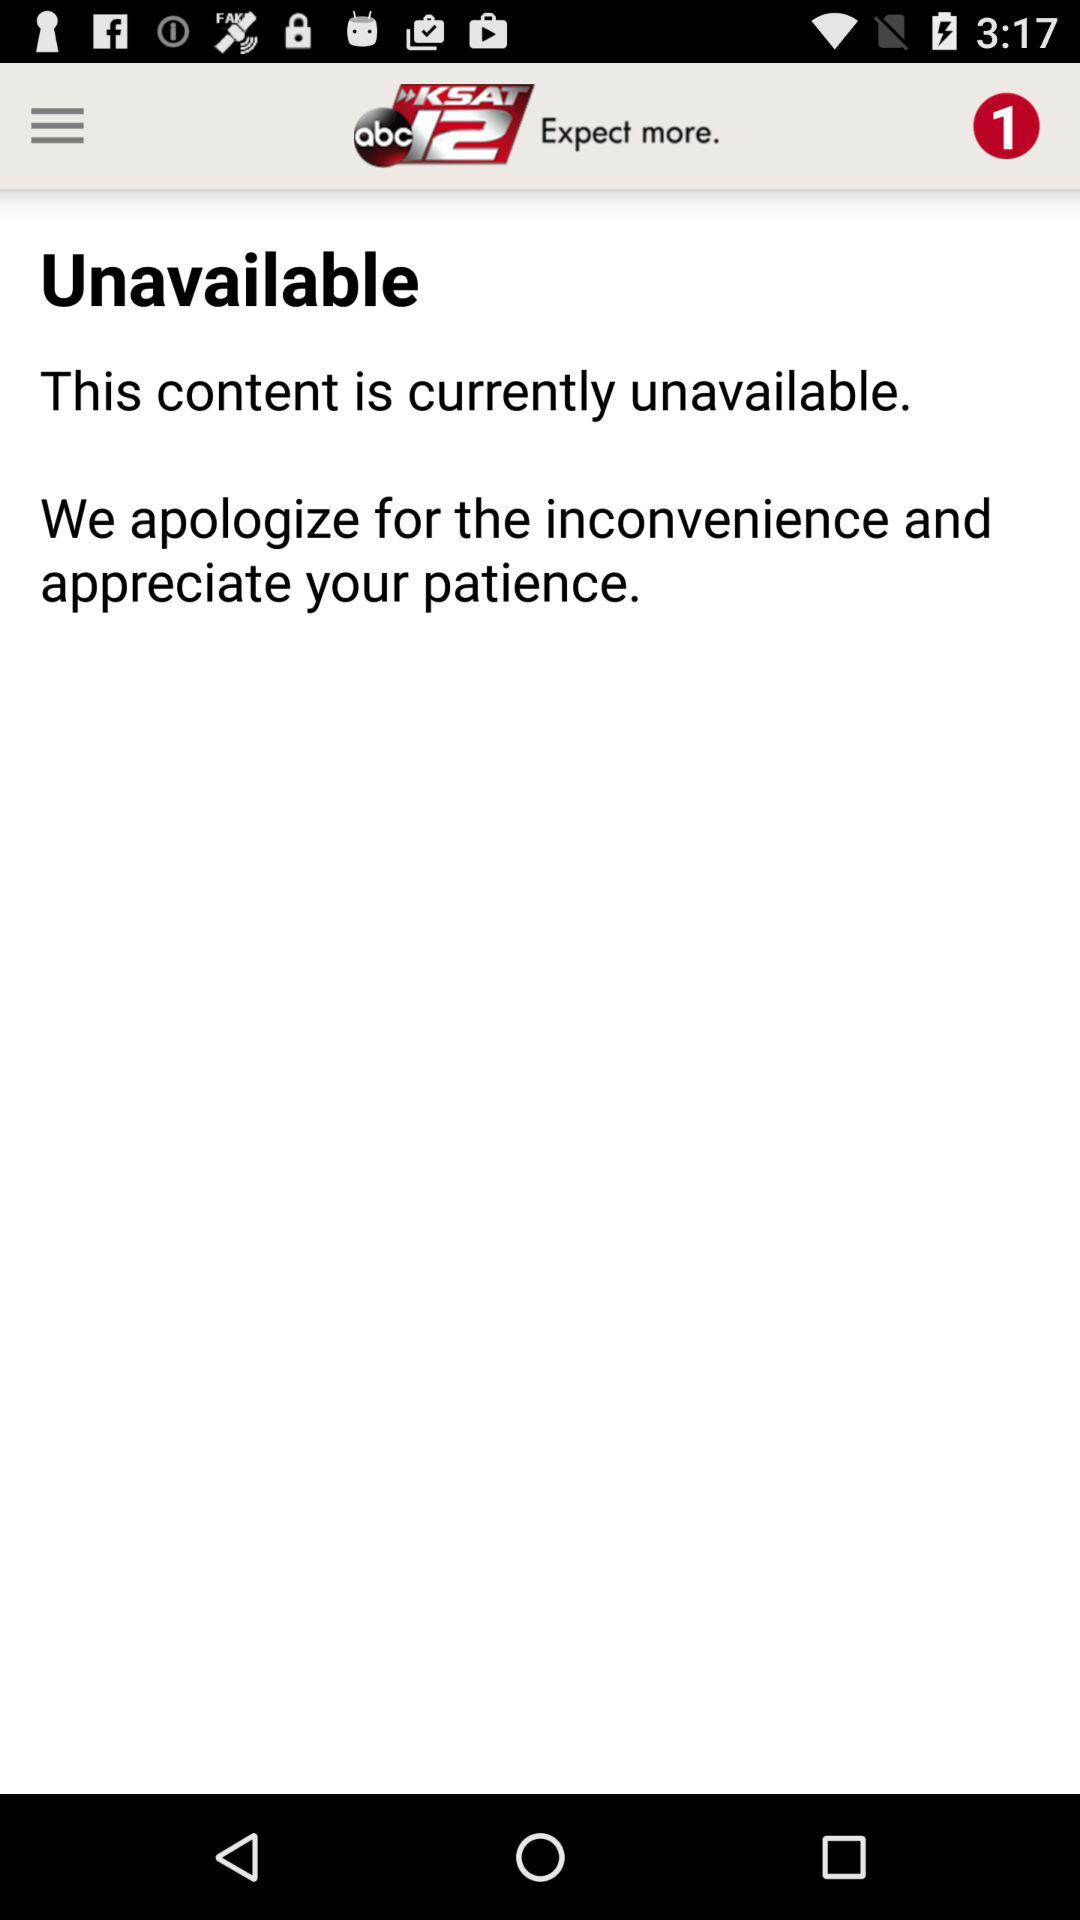Is there any content available? The content is currently unavailable. 